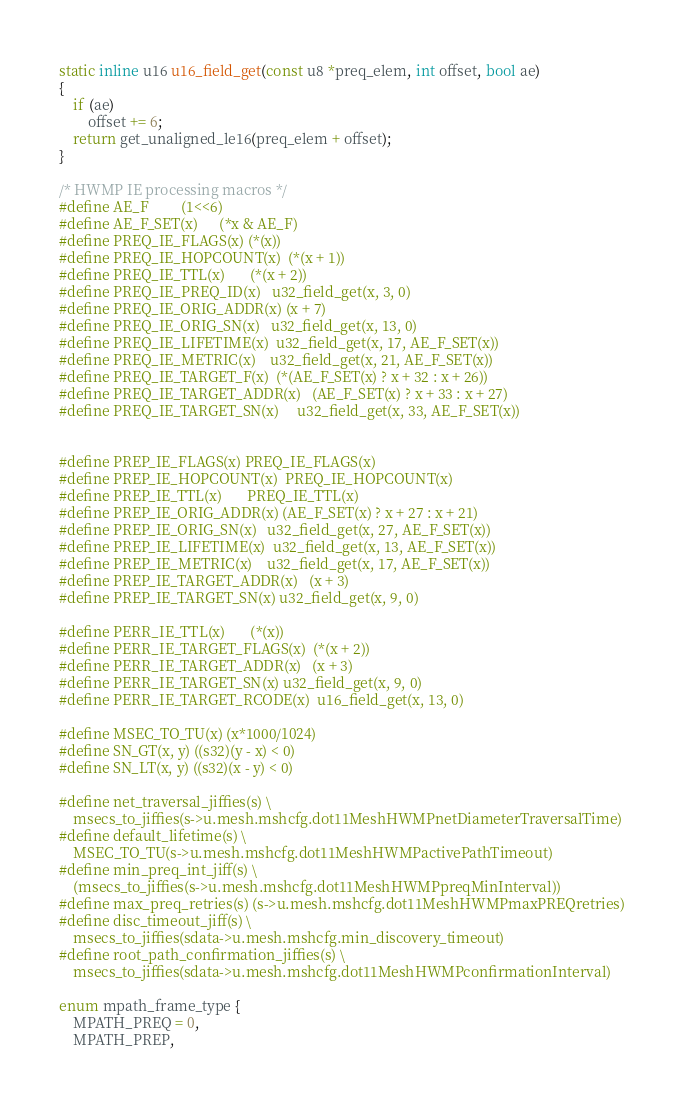<code> <loc_0><loc_0><loc_500><loc_500><_C_>
static inline u16 u16_field_get(const u8 *preq_elem, int offset, bool ae)
{
	if (ae)
		offset += 6;
	return get_unaligned_le16(preq_elem + offset);
}

/* HWMP IE processing macros */
#define AE_F			(1<<6)
#define AE_F_SET(x)		(*x & AE_F)
#define PREQ_IE_FLAGS(x)	(*(x))
#define PREQ_IE_HOPCOUNT(x)	(*(x + 1))
#define PREQ_IE_TTL(x)		(*(x + 2))
#define PREQ_IE_PREQ_ID(x)	u32_field_get(x, 3, 0)
#define PREQ_IE_ORIG_ADDR(x)	(x + 7)
#define PREQ_IE_ORIG_SN(x)	u32_field_get(x, 13, 0)
#define PREQ_IE_LIFETIME(x)	u32_field_get(x, 17, AE_F_SET(x))
#define PREQ_IE_METRIC(x) 	u32_field_get(x, 21, AE_F_SET(x))
#define PREQ_IE_TARGET_F(x)	(*(AE_F_SET(x) ? x + 32 : x + 26))
#define PREQ_IE_TARGET_ADDR(x) 	(AE_F_SET(x) ? x + 33 : x + 27)
#define PREQ_IE_TARGET_SN(x) 	u32_field_get(x, 33, AE_F_SET(x))


#define PREP_IE_FLAGS(x)	PREQ_IE_FLAGS(x)
#define PREP_IE_HOPCOUNT(x)	PREQ_IE_HOPCOUNT(x)
#define PREP_IE_TTL(x)		PREQ_IE_TTL(x)
#define PREP_IE_ORIG_ADDR(x)	(AE_F_SET(x) ? x + 27 : x + 21)
#define PREP_IE_ORIG_SN(x)	u32_field_get(x, 27, AE_F_SET(x))
#define PREP_IE_LIFETIME(x)	u32_field_get(x, 13, AE_F_SET(x))
#define PREP_IE_METRIC(x)	u32_field_get(x, 17, AE_F_SET(x))
#define PREP_IE_TARGET_ADDR(x)	(x + 3)
#define PREP_IE_TARGET_SN(x)	u32_field_get(x, 9, 0)

#define PERR_IE_TTL(x)		(*(x))
#define PERR_IE_TARGET_FLAGS(x)	(*(x + 2))
#define PERR_IE_TARGET_ADDR(x)	(x + 3)
#define PERR_IE_TARGET_SN(x)	u32_field_get(x, 9, 0)
#define PERR_IE_TARGET_RCODE(x)	u16_field_get(x, 13, 0)

#define MSEC_TO_TU(x) (x*1000/1024)
#define SN_GT(x, y) ((s32)(y - x) < 0)
#define SN_LT(x, y) ((s32)(x - y) < 0)

#define net_traversal_jiffies(s) \
	msecs_to_jiffies(s->u.mesh.mshcfg.dot11MeshHWMPnetDiameterTraversalTime)
#define default_lifetime(s) \
	MSEC_TO_TU(s->u.mesh.mshcfg.dot11MeshHWMPactivePathTimeout)
#define min_preq_int_jiff(s) \
	(msecs_to_jiffies(s->u.mesh.mshcfg.dot11MeshHWMPpreqMinInterval))
#define max_preq_retries(s) (s->u.mesh.mshcfg.dot11MeshHWMPmaxPREQretries)
#define disc_timeout_jiff(s) \
	msecs_to_jiffies(sdata->u.mesh.mshcfg.min_discovery_timeout)
#define root_path_confirmation_jiffies(s) \
	msecs_to_jiffies(sdata->u.mesh.mshcfg.dot11MeshHWMPconfirmationInterval)

enum mpath_frame_type {
	MPATH_PREQ = 0,
	MPATH_PREP,</code> 